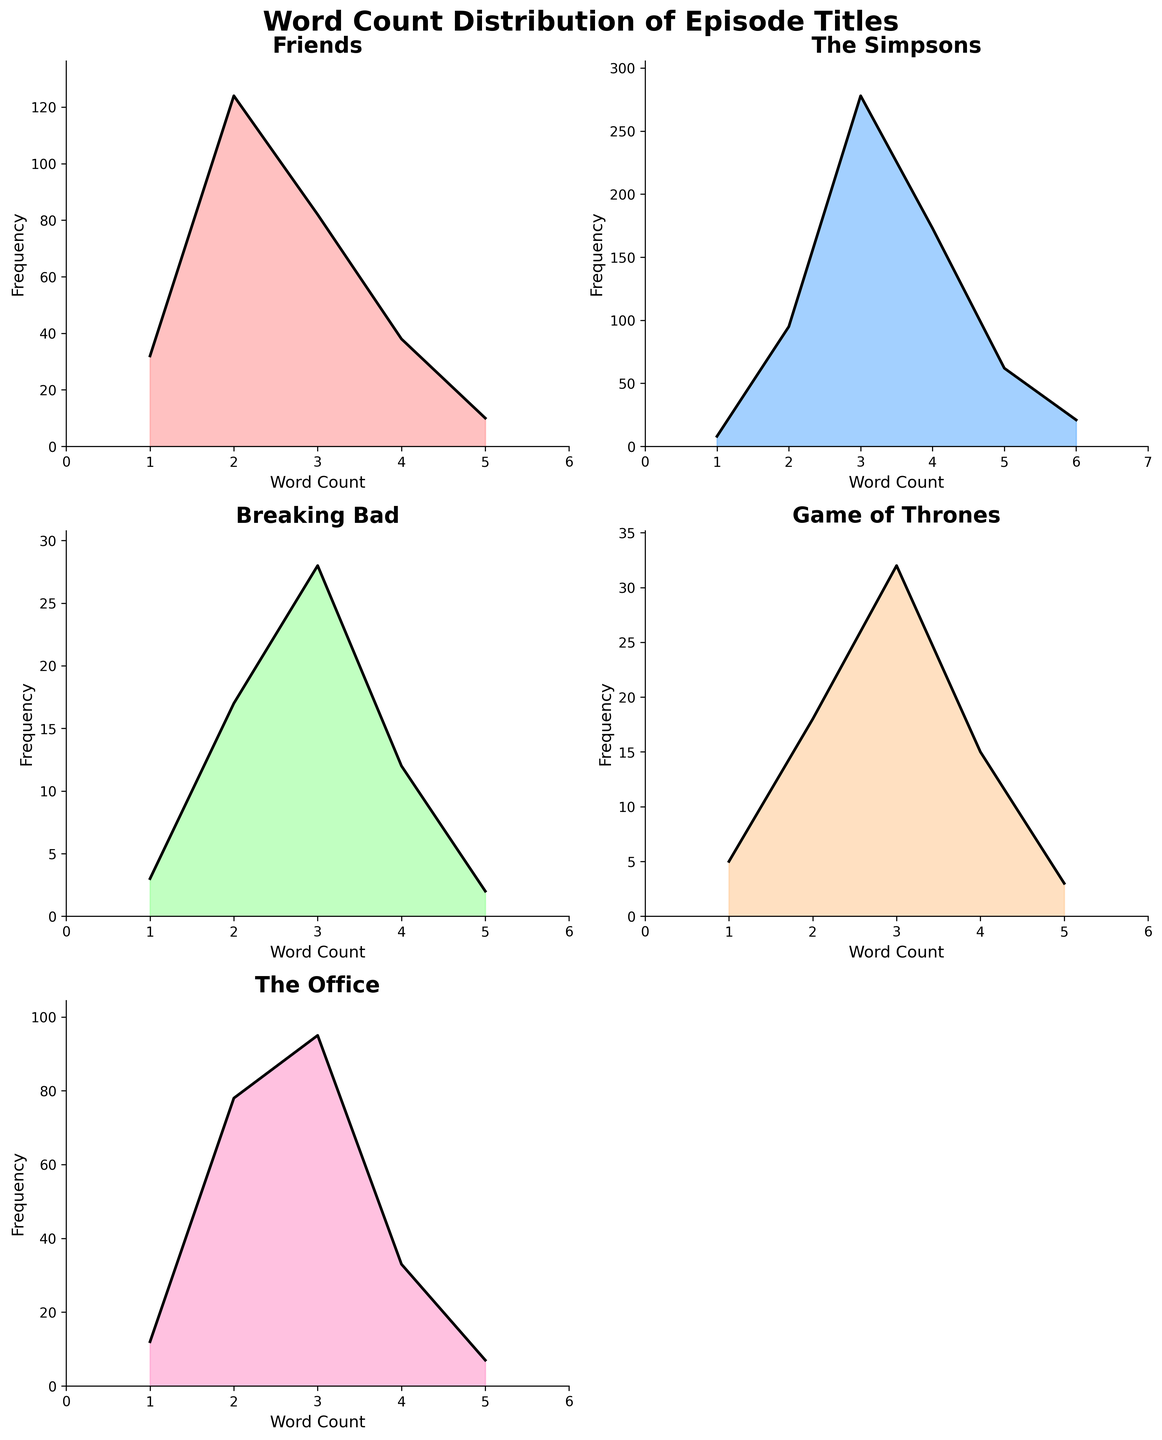What is the title of the figure? The title of the figure is displayed at the top and reads "Word Count Distribution of Episode Titles".
Answer: Word Count Distribution of Episode Titles How many subplots are displayed in the figure? The figure is divided into six subplots arranged in a 3x2 layout.
Answer: 6 Which series has the highest frequency for a word count of 3? By comparing the density plots, "The Simpsons" has the highest frequency for a word count of 3 with 278.
Answer: The Simpsons Which subplot has the least variation in frequency values? By visually inspecting the variation in frequency values across the density plots, "Breaking Bad" has the least variation in its plot.
Answer: Breaking Bad What is the maximum word count used in episode titles for "Friends"? The "Friends" subplot shows word counts up to 5 on the x-axis.
Answer: 5 What is the frequency of two-word episode titles in "The Office"? In the "The Office" subplot, the frequency for two-word titles is 78.
Answer: 78 Arrange the series in descending order based on the maximum frequency value observed in their density plots. By comparing the peaks of the density plots, arrange as follows: "The Simpsons" (278), "Friends" (124), "The Office" (95), "Game of Thrones" (32), and "Breaking Bad" (28).
Answer: The Simpsons, Friends, The Office, Game of Thrones, Breaking Bad For which word count do "Friends" and "Game of Thrones" have the same frequency? By comparing plots for "Friends" and "Game of Thrones," they both have a frequency of 5 for one-word episode titles.
Answer: 1 Which series exhibits a word count distribution skewed towards lower word counts? By examining the density plots, "Breaking Bad" shows a higher concentration of lower word counts (mostly 1 and 2).
Answer: Breaking Bad 